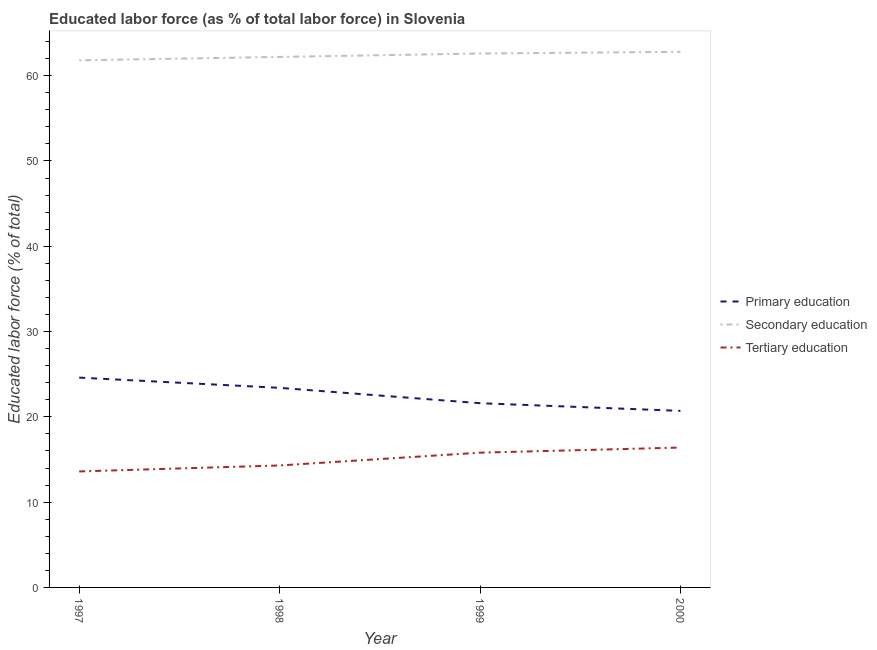How many different coloured lines are there?
Provide a short and direct response. 3. Is the number of lines equal to the number of legend labels?
Ensure brevity in your answer.  Yes. What is the percentage of labor force who received secondary education in 1998?
Provide a succinct answer. 62.2. Across all years, what is the maximum percentage of labor force who received tertiary education?
Your answer should be very brief. 16.4. Across all years, what is the minimum percentage of labor force who received primary education?
Your response must be concise. 20.7. In which year was the percentage of labor force who received tertiary education minimum?
Your response must be concise. 1997. What is the total percentage of labor force who received primary education in the graph?
Provide a short and direct response. 90.3. What is the difference between the percentage of labor force who received secondary education in 1997 and that in 1998?
Your response must be concise. -0.4. What is the difference between the percentage of labor force who received primary education in 1997 and the percentage of labor force who received secondary education in 2000?
Your answer should be very brief. -38.2. What is the average percentage of labor force who received primary education per year?
Offer a very short reply. 22.58. In the year 1999, what is the difference between the percentage of labor force who received secondary education and percentage of labor force who received tertiary education?
Provide a short and direct response. 46.8. What is the ratio of the percentage of labor force who received tertiary education in 1998 to that in 1999?
Offer a very short reply. 0.91. Is the percentage of labor force who received secondary education in 1997 less than that in 1999?
Provide a succinct answer. Yes. What is the difference between the highest and the second highest percentage of labor force who received primary education?
Offer a terse response. 1.2. What is the difference between the highest and the lowest percentage of labor force who received tertiary education?
Keep it short and to the point. 2.8. In how many years, is the percentage of labor force who received primary education greater than the average percentage of labor force who received primary education taken over all years?
Keep it short and to the point. 2. Does the percentage of labor force who received primary education monotonically increase over the years?
Offer a very short reply. No. Is the percentage of labor force who received tertiary education strictly greater than the percentage of labor force who received secondary education over the years?
Provide a short and direct response. No. Is the percentage of labor force who received secondary education strictly less than the percentage of labor force who received primary education over the years?
Make the answer very short. No. How many years are there in the graph?
Provide a succinct answer. 4. What is the difference between two consecutive major ticks on the Y-axis?
Your answer should be very brief. 10. Does the graph contain grids?
Make the answer very short. No. Where does the legend appear in the graph?
Your response must be concise. Center right. How many legend labels are there?
Make the answer very short. 3. What is the title of the graph?
Offer a very short reply. Educated labor force (as % of total labor force) in Slovenia. Does "Capital account" appear as one of the legend labels in the graph?
Offer a terse response. No. What is the label or title of the Y-axis?
Keep it short and to the point. Educated labor force (% of total). What is the Educated labor force (% of total) in Primary education in 1997?
Provide a short and direct response. 24.6. What is the Educated labor force (% of total) of Secondary education in 1997?
Offer a terse response. 61.8. What is the Educated labor force (% of total) in Tertiary education in 1997?
Offer a terse response. 13.6. What is the Educated labor force (% of total) of Primary education in 1998?
Your answer should be very brief. 23.4. What is the Educated labor force (% of total) in Secondary education in 1998?
Your response must be concise. 62.2. What is the Educated labor force (% of total) of Tertiary education in 1998?
Your answer should be very brief. 14.3. What is the Educated labor force (% of total) in Primary education in 1999?
Your response must be concise. 21.6. What is the Educated labor force (% of total) of Secondary education in 1999?
Your answer should be compact. 62.6. What is the Educated labor force (% of total) of Tertiary education in 1999?
Keep it short and to the point. 15.8. What is the Educated labor force (% of total) in Primary education in 2000?
Offer a terse response. 20.7. What is the Educated labor force (% of total) in Secondary education in 2000?
Make the answer very short. 62.8. What is the Educated labor force (% of total) of Tertiary education in 2000?
Give a very brief answer. 16.4. Across all years, what is the maximum Educated labor force (% of total) of Primary education?
Keep it short and to the point. 24.6. Across all years, what is the maximum Educated labor force (% of total) in Secondary education?
Your answer should be compact. 62.8. Across all years, what is the maximum Educated labor force (% of total) in Tertiary education?
Your answer should be very brief. 16.4. Across all years, what is the minimum Educated labor force (% of total) in Primary education?
Your response must be concise. 20.7. Across all years, what is the minimum Educated labor force (% of total) of Secondary education?
Offer a terse response. 61.8. Across all years, what is the minimum Educated labor force (% of total) of Tertiary education?
Your answer should be compact. 13.6. What is the total Educated labor force (% of total) in Primary education in the graph?
Your response must be concise. 90.3. What is the total Educated labor force (% of total) in Secondary education in the graph?
Offer a very short reply. 249.4. What is the total Educated labor force (% of total) of Tertiary education in the graph?
Offer a terse response. 60.1. What is the difference between the Educated labor force (% of total) in Primary education in 1997 and that in 1998?
Offer a very short reply. 1.2. What is the difference between the Educated labor force (% of total) of Secondary education in 1997 and that in 1999?
Ensure brevity in your answer.  -0.8. What is the difference between the Educated labor force (% of total) of Secondary education in 1997 and that in 2000?
Make the answer very short. -1. What is the difference between the Educated labor force (% of total) of Tertiary education in 1997 and that in 2000?
Ensure brevity in your answer.  -2.8. What is the difference between the Educated labor force (% of total) of Primary education in 1998 and that in 1999?
Provide a succinct answer. 1.8. What is the difference between the Educated labor force (% of total) in Secondary education in 1998 and that in 1999?
Your response must be concise. -0.4. What is the difference between the Educated labor force (% of total) of Tertiary education in 1998 and that in 1999?
Your response must be concise. -1.5. What is the difference between the Educated labor force (% of total) of Primary education in 1998 and that in 2000?
Ensure brevity in your answer.  2.7. What is the difference between the Educated labor force (% of total) in Secondary education in 1998 and that in 2000?
Offer a very short reply. -0.6. What is the difference between the Educated labor force (% of total) of Tertiary education in 1998 and that in 2000?
Offer a terse response. -2.1. What is the difference between the Educated labor force (% of total) in Secondary education in 1999 and that in 2000?
Make the answer very short. -0.2. What is the difference between the Educated labor force (% of total) in Tertiary education in 1999 and that in 2000?
Provide a succinct answer. -0.6. What is the difference between the Educated labor force (% of total) of Primary education in 1997 and the Educated labor force (% of total) of Secondary education in 1998?
Your response must be concise. -37.6. What is the difference between the Educated labor force (% of total) in Secondary education in 1997 and the Educated labor force (% of total) in Tertiary education in 1998?
Give a very brief answer. 47.5. What is the difference between the Educated labor force (% of total) of Primary education in 1997 and the Educated labor force (% of total) of Secondary education in 1999?
Make the answer very short. -38. What is the difference between the Educated labor force (% of total) of Primary education in 1997 and the Educated labor force (% of total) of Tertiary education in 1999?
Provide a succinct answer. 8.8. What is the difference between the Educated labor force (% of total) in Secondary education in 1997 and the Educated labor force (% of total) in Tertiary education in 1999?
Ensure brevity in your answer.  46. What is the difference between the Educated labor force (% of total) of Primary education in 1997 and the Educated labor force (% of total) of Secondary education in 2000?
Your response must be concise. -38.2. What is the difference between the Educated labor force (% of total) in Secondary education in 1997 and the Educated labor force (% of total) in Tertiary education in 2000?
Offer a terse response. 45.4. What is the difference between the Educated labor force (% of total) of Primary education in 1998 and the Educated labor force (% of total) of Secondary education in 1999?
Give a very brief answer. -39.2. What is the difference between the Educated labor force (% of total) of Primary education in 1998 and the Educated labor force (% of total) of Tertiary education in 1999?
Provide a succinct answer. 7.6. What is the difference between the Educated labor force (% of total) of Secondary education in 1998 and the Educated labor force (% of total) of Tertiary education in 1999?
Your answer should be very brief. 46.4. What is the difference between the Educated labor force (% of total) in Primary education in 1998 and the Educated labor force (% of total) in Secondary education in 2000?
Your answer should be compact. -39.4. What is the difference between the Educated labor force (% of total) in Secondary education in 1998 and the Educated labor force (% of total) in Tertiary education in 2000?
Offer a very short reply. 45.8. What is the difference between the Educated labor force (% of total) in Primary education in 1999 and the Educated labor force (% of total) in Secondary education in 2000?
Give a very brief answer. -41.2. What is the difference between the Educated labor force (% of total) in Primary education in 1999 and the Educated labor force (% of total) in Tertiary education in 2000?
Offer a very short reply. 5.2. What is the difference between the Educated labor force (% of total) in Secondary education in 1999 and the Educated labor force (% of total) in Tertiary education in 2000?
Your answer should be very brief. 46.2. What is the average Educated labor force (% of total) of Primary education per year?
Make the answer very short. 22.57. What is the average Educated labor force (% of total) in Secondary education per year?
Keep it short and to the point. 62.35. What is the average Educated labor force (% of total) in Tertiary education per year?
Your response must be concise. 15.03. In the year 1997, what is the difference between the Educated labor force (% of total) in Primary education and Educated labor force (% of total) in Secondary education?
Offer a terse response. -37.2. In the year 1997, what is the difference between the Educated labor force (% of total) of Secondary education and Educated labor force (% of total) of Tertiary education?
Offer a terse response. 48.2. In the year 1998, what is the difference between the Educated labor force (% of total) in Primary education and Educated labor force (% of total) in Secondary education?
Keep it short and to the point. -38.8. In the year 1998, what is the difference between the Educated labor force (% of total) in Secondary education and Educated labor force (% of total) in Tertiary education?
Your answer should be compact. 47.9. In the year 1999, what is the difference between the Educated labor force (% of total) of Primary education and Educated labor force (% of total) of Secondary education?
Provide a short and direct response. -41. In the year 1999, what is the difference between the Educated labor force (% of total) in Primary education and Educated labor force (% of total) in Tertiary education?
Provide a short and direct response. 5.8. In the year 1999, what is the difference between the Educated labor force (% of total) in Secondary education and Educated labor force (% of total) in Tertiary education?
Keep it short and to the point. 46.8. In the year 2000, what is the difference between the Educated labor force (% of total) in Primary education and Educated labor force (% of total) in Secondary education?
Your answer should be compact. -42.1. In the year 2000, what is the difference between the Educated labor force (% of total) of Secondary education and Educated labor force (% of total) of Tertiary education?
Provide a short and direct response. 46.4. What is the ratio of the Educated labor force (% of total) of Primary education in 1997 to that in 1998?
Provide a short and direct response. 1.05. What is the ratio of the Educated labor force (% of total) of Tertiary education in 1997 to that in 1998?
Make the answer very short. 0.95. What is the ratio of the Educated labor force (% of total) in Primary education in 1997 to that in 1999?
Provide a succinct answer. 1.14. What is the ratio of the Educated labor force (% of total) in Secondary education in 1997 to that in 1999?
Your answer should be very brief. 0.99. What is the ratio of the Educated labor force (% of total) of Tertiary education in 1997 to that in 1999?
Provide a short and direct response. 0.86. What is the ratio of the Educated labor force (% of total) of Primary education in 1997 to that in 2000?
Give a very brief answer. 1.19. What is the ratio of the Educated labor force (% of total) in Secondary education in 1997 to that in 2000?
Offer a very short reply. 0.98. What is the ratio of the Educated labor force (% of total) of Tertiary education in 1997 to that in 2000?
Make the answer very short. 0.83. What is the ratio of the Educated labor force (% of total) of Secondary education in 1998 to that in 1999?
Offer a very short reply. 0.99. What is the ratio of the Educated labor force (% of total) in Tertiary education in 1998 to that in 1999?
Offer a terse response. 0.91. What is the ratio of the Educated labor force (% of total) of Primary education in 1998 to that in 2000?
Offer a very short reply. 1.13. What is the ratio of the Educated labor force (% of total) in Secondary education in 1998 to that in 2000?
Your answer should be very brief. 0.99. What is the ratio of the Educated labor force (% of total) in Tertiary education in 1998 to that in 2000?
Offer a very short reply. 0.87. What is the ratio of the Educated labor force (% of total) of Primary education in 1999 to that in 2000?
Offer a very short reply. 1.04. What is the ratio of the Educated labor force (% of total) of Tertiary education in 1999 to that in 2000?
Keep it short and to the point. 0.96. What is the difference between the highest and the lowest Educated labor force (% of total) of Secondary education?
Provide a succinct answer. 1. What is the difference between the highest and the lowest Educated labor force (% of total) in Tertiary education?
Ensure brevity in your answer.  2.8. 